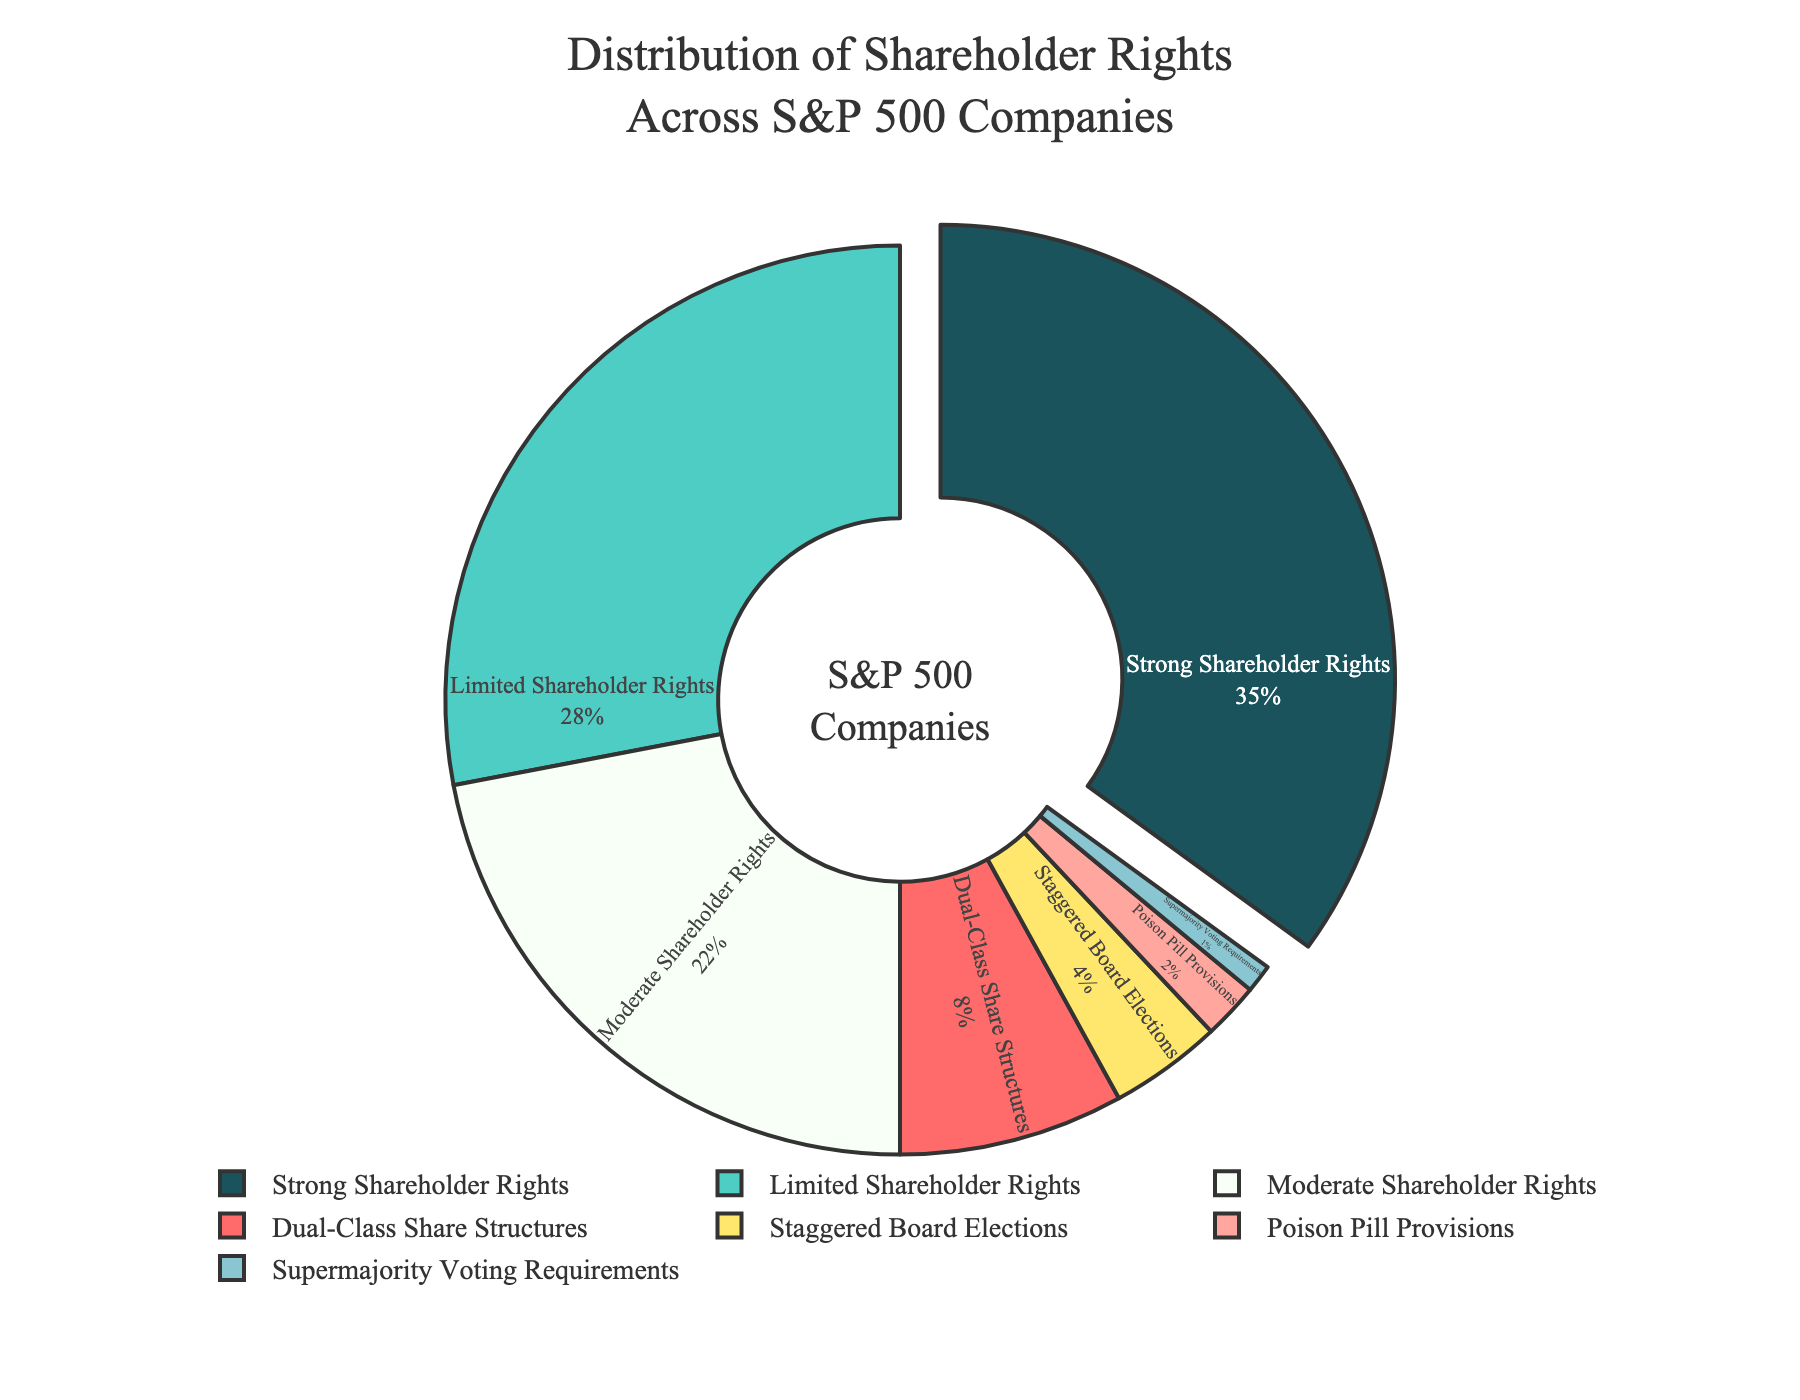What percentage of companies have moderate or strong shareholder rights? Sum the percentages of 'Strong Shareholder Rights' (35%) and 'Moderate Shareholder Rights' (22%). Therefore, 35% + 22% = 57%.
Answer: 57% Which category has the highest percentage of shareholder rights in S&P 500 companies? Identify the segment with the largest value; it is 'Strong Shareholder Rights' at 35%.
Answer: Strong Shareholder Rights How much larger is the percentage of companies with strong shareholder rights compared to those with dual-class share structures? Subtract the percentage of 'Dual-Class Share Structures' (8%) from 'Strong Shareholder Rights' (35%). Therefore, 35% - 8% = 27%.
Answer: 27% What is the combined percentage of companies with dual-class share structures, staggered board elections, and poison pill provisions? Sum the percentages of 'Dual-Class Share Structures' (8%), 'Staggered Board Elections' (4%), and 'Poison Pill Provisions' (2%). Hence, 8% + 4% + 2% = 14%.
Answer: 14% How does the percentage of companies with supermajority voting requirements visually compare to those with staggered board elections? Observe the size of the segments in the pie chart; 'Supermajority Voting Requirements' (1%) is significantly smaller than 'Staggered Board Elections' (4%).
Answer: Smaller Is there any category that alone constitutes more than one-third of the entire shareholder rights distribution? Check if any segment exceeds 33.3%; 'Strong Shareholder Rights' at 35% does.
Answer: Yes Which two categories combined are closest in percentage to the category with the largest distribution? Find the sum of suitable combinations. 'Limited Shareholder Rights' (28%) + 'Moderate Shareholder Rights' (22%) = 50%. Compare it to 'Strong Shareholder Rights' (35%).
Answer: Limited Shareholder Rights and Moderate Shareholder Rights What percentage of companies have limited shareholder rights or less? Sum the percentages of 'Limited Shareholder Rights' (28%) and all categories below it. Therefore, 28% + 22% + 8% + 4% + 2% + 1% = 65%.
Answer: 65% Which color represents the category with the smallest percentage of companies? Identify the color associated with the 'Supermajority Voting Requirements' (1%) segment in the pie chart.
Answer: Light Blue 